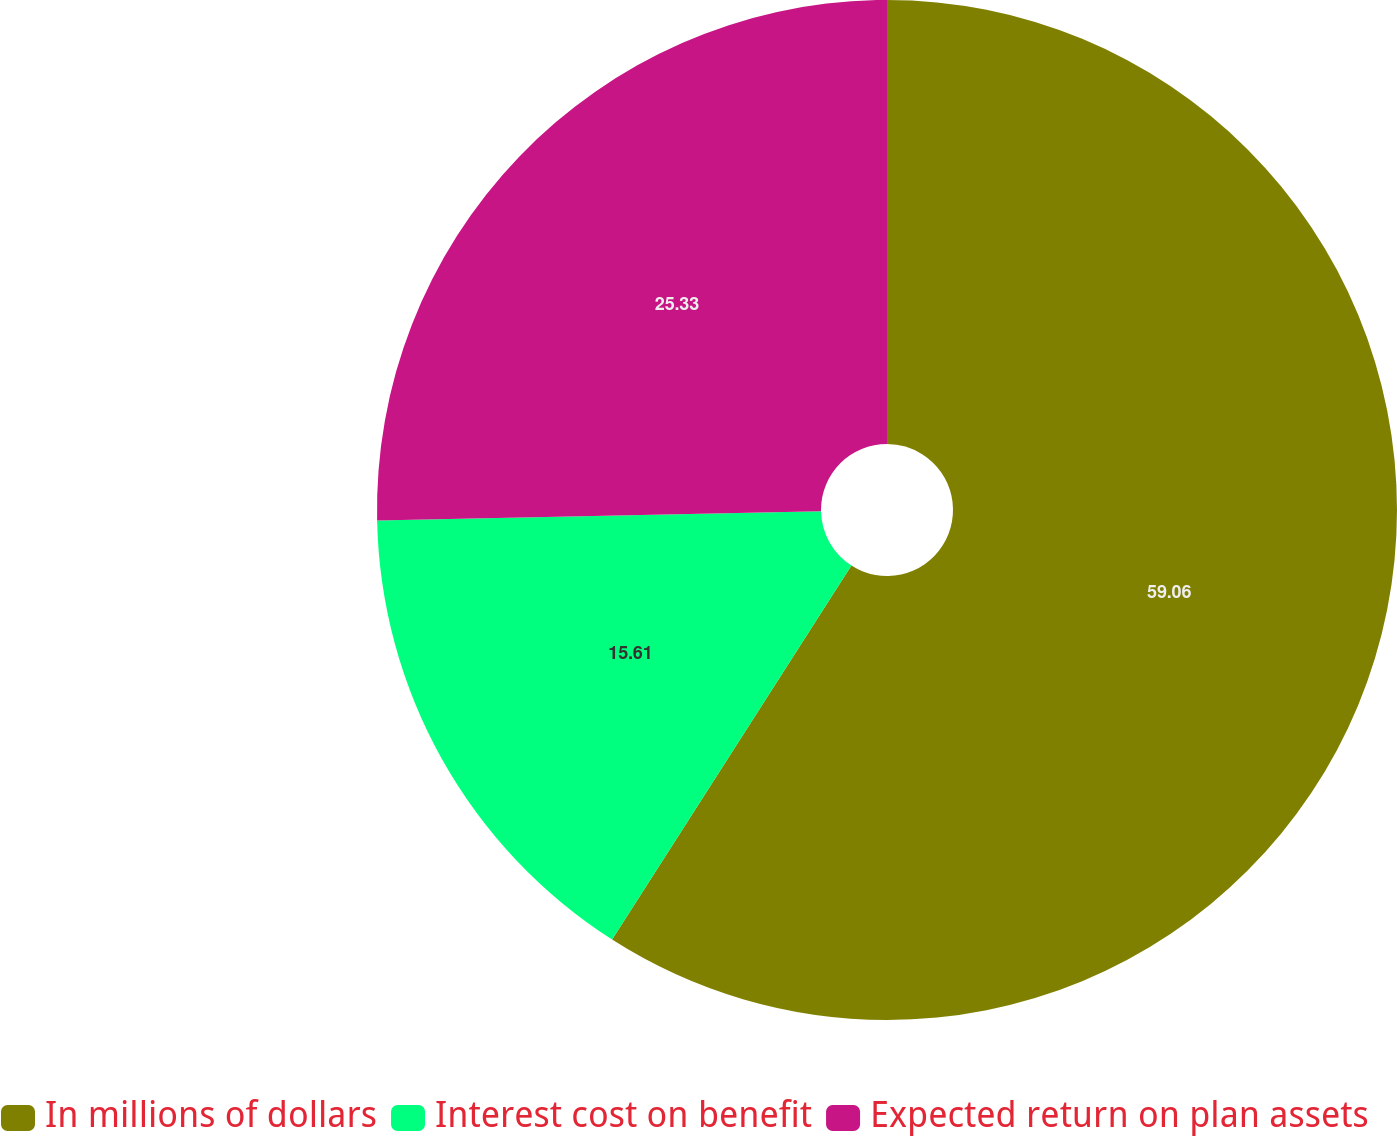Convert chart to OTSL. <chart><loc_0><loc_0><loc_500><loc_500><pie_chart><fcel>In millions of dollars<fcel>Interest cost on benefit<fcel>Expected return on plan assets<nl><fcel>59.06%<fcel>15.61%<fcel>25.33%<nl></chart> 